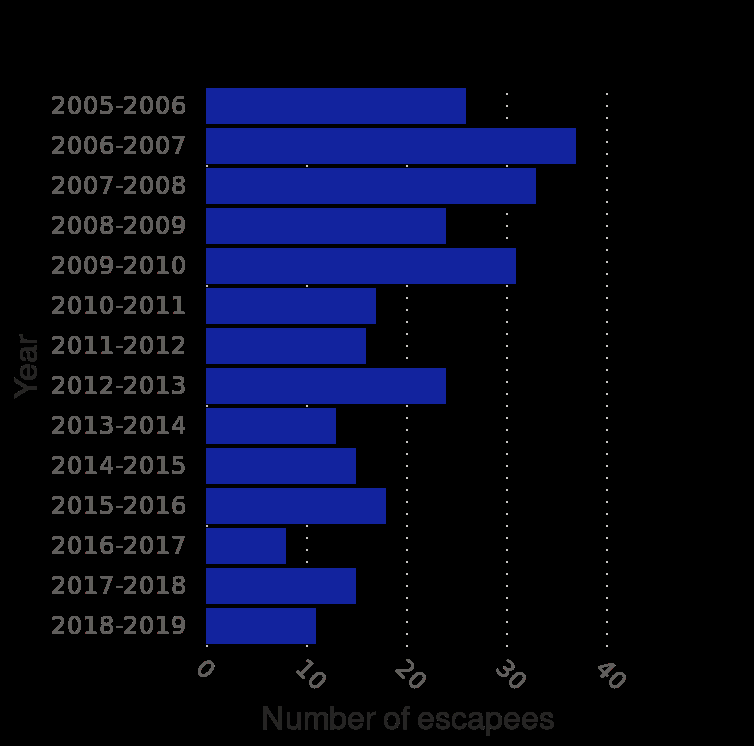<image>
What year had the greatest number of escapes?  The greatest number of escapes was in 2006 to 2007. How many escapes were there in the year with the highest number of escapes? There were almost 40 escapes in 2006 to 2007. How many escapes were there in 2016 to 2017?  There were less than 10 escapes in 2016 to 2017. 